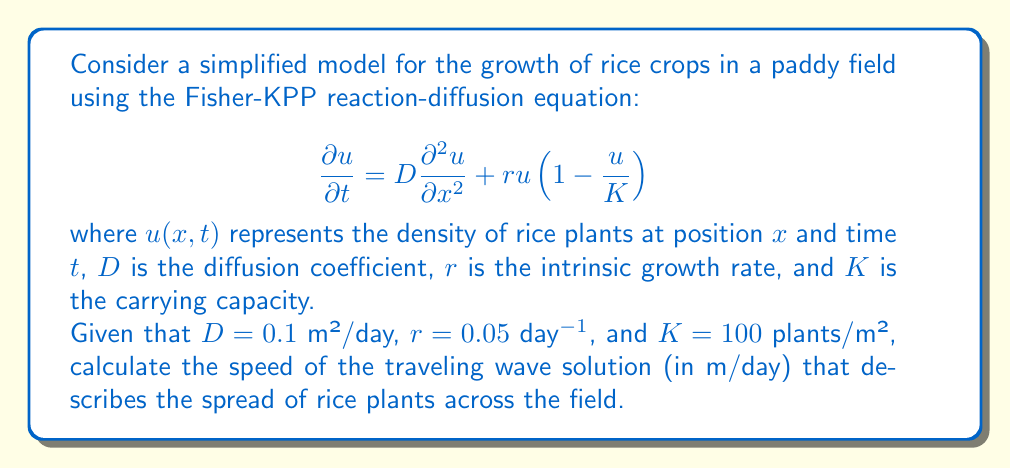Give your solution to this math problem. To solve this problem, we'll use the formula for the speed of the traveling wave solution in the Fisher-KPP equation. The steps are as follows:

1. The speed of the traveling wave solution for the Fisher-KPP equation is given by:

   $$c = 2\sqrt{rD}$$

   where $c$ is the wave speed, $r$ is the intrinsic growth rate, and $D$ is the diffusion coefficient.

2. We are given the following values:
   - $D = 0.1$ m²/day
   - $r = 0.05$ day⁻¹

3. Substituting these values into the formula:

   $$c = 2\sqrt{(0.05\text{ day}^{-1})(0.1\text{ m}^2/\text{day})}$$

4. Simplify under the square root:

   $$c = 2\sqrt{0.005\text{ m}^2/\text{day}^2}$$

5. Calculate the square root:

   $$c = 2(0.0707\text{ m/day})$$

6. Multiply:

   $$c = 0.1414\text{ m/day}$$

This result represents the speed at which the rice plants spread across the field according to this simplified model.
Answer: The speed of the traveling wave solution is approximately 0.1414 m/day. 